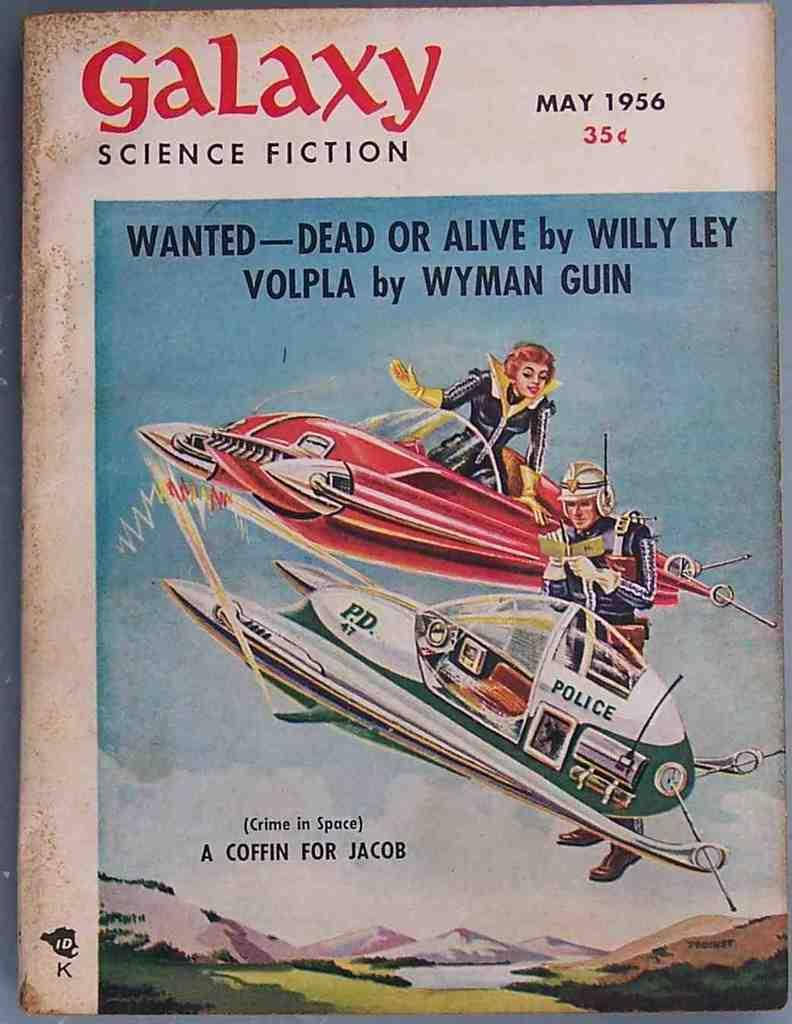What is depicted on the poster in the image? The poster contains a painting of an aircraft. What else can be seen in the painting on the poster? The painting includes two people. What type of landscape is visible in the image? There are hills and water visible in the image. What type of trousers are the people wearing in the painting on the poster? There is no information about the type of trousers the people are wearing in the painting on the poster. --- Facts: 1. There is a person sitting on a chair. 2. The person is holding a book. 3. The book has a red cover. 4. There is a table next to the chair. 5. There is a lamp on the table. Absurd Topics: parrot, ocean, dance Conversation: What is the person in the image doing? The person is sitting on a chair. What object is the person holding? The person is holding a book. What can be said about the book's appearance? The book has a red cover. What furniture is present near the chair? There is a table next to the chair. What object is on the table? There is a lamp on the table. Reasoning: Let's think step by step in order to produce the conversation. We start by identifying the main subject of the image, which is the person sitting on a chair. Then, we expand the conversation to include other details about the person's actions, such as holding a book. Next, we describe the appearance of the book, including its red cover. Finally, we mention the presence of a table and a lamp on the table. Absurd Question/Answer: Can you tell me how many parrots are sitting on the person's shoulder in the image? There are no parrots present in the image. --- Facts: 1. There is a group of people standing in a circle. 2. The people are holding hands. 3. The people are wearing matching shirts. 4. There is a banner in the background. 5. The banner has text on it. Absurd Topics: bicycle, rainbow, guitar Conversation: What are the people in the image doing? The people are standing in a circle. How are the people connected in the image? The people are holding hands. What do the people have in common in terms of clothing? The people are wearing matching shirts. What can be seen in the background of the image? There is a banner in the background. What information is provided on the banner? The banner has text on it. Reasoning: Let's think step by step in order to produce the conversation. We start by identifying the main subject of the image, which is the group of people standing in a circle. Then, we expand the conversation to include 